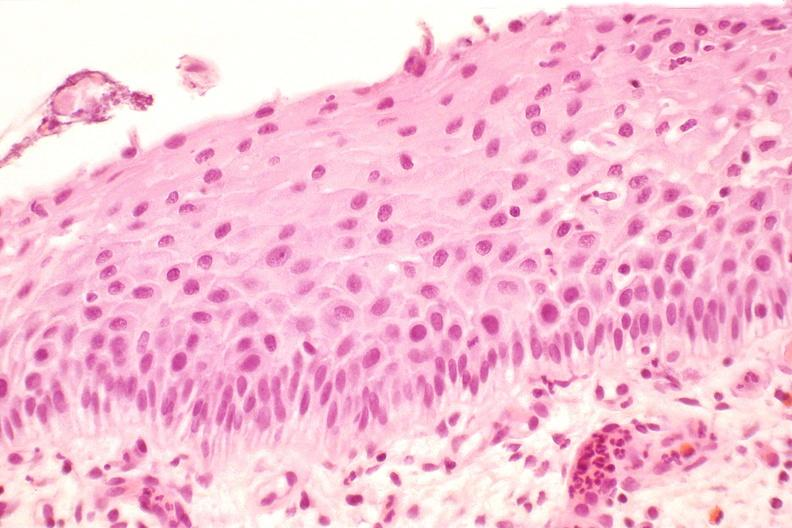where is this from?
Answer the question using a single word or phrase. Female reproductive system 